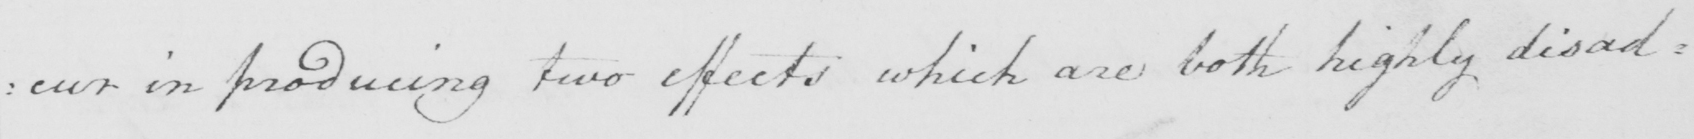Please transcribe the handwritten text in this image. : cur in producing two effects which are both highly disad : 